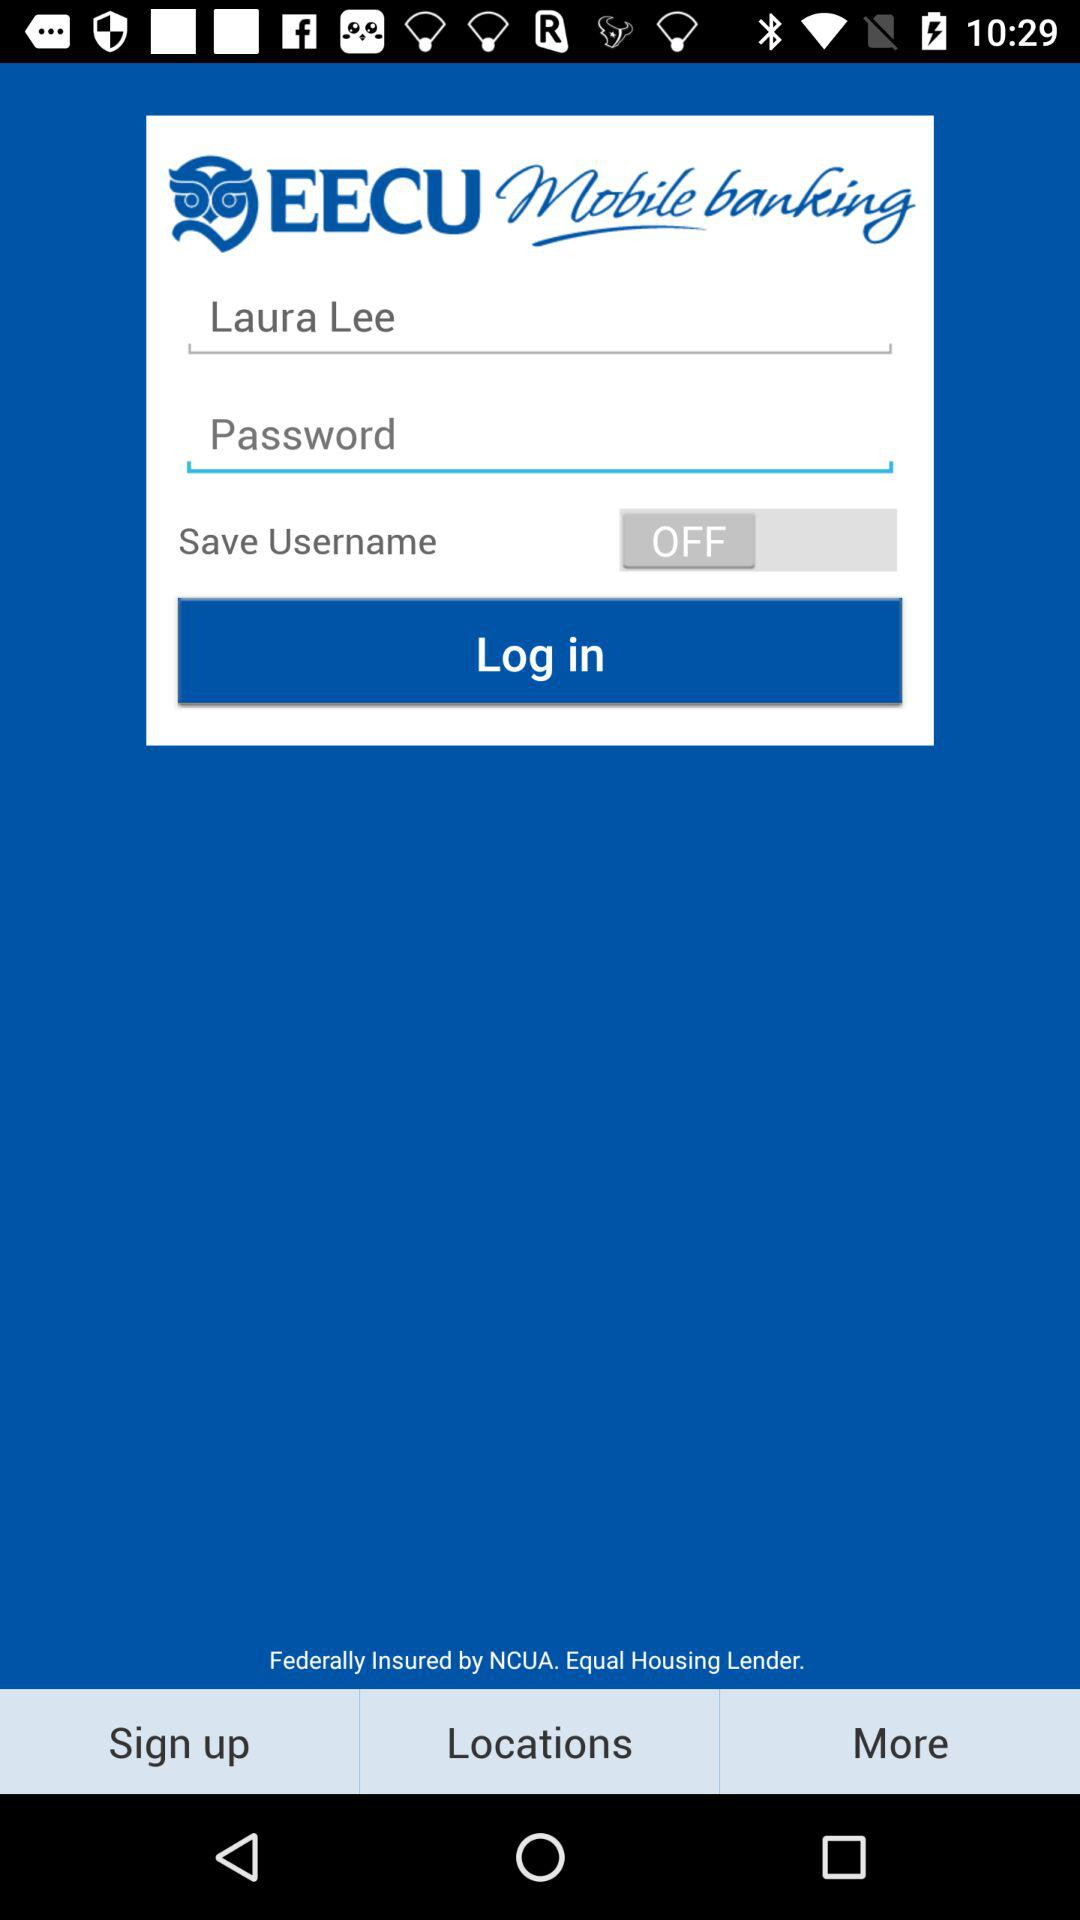What is the status of "Save Username"? The status is "off". 